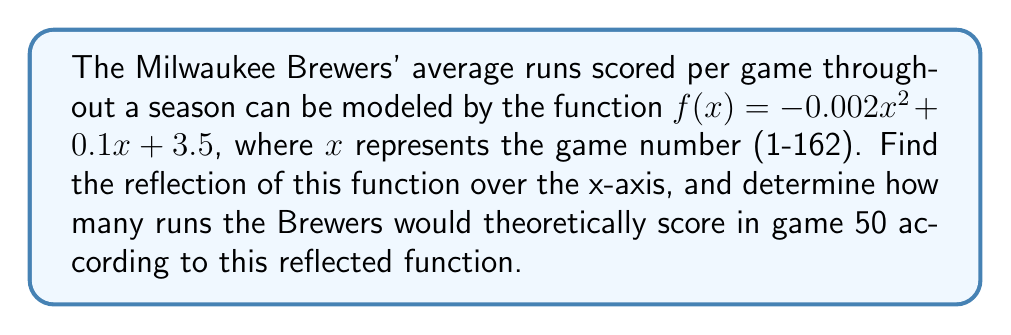Can you answer this question? To solve this problem, we'll follow these steps:

1) To reflect a function over the x-axis, we multiply the entire function by -1. This gives us:
   $g(x) = -f(x) = -(-0.002x^2 + 0.1x + 3.5)$
   
2) Simplify by distributing the negative sign:
   $g(x) = 0.002x^2 - 0.1x - 3.5$

3) Now we have our reflected function. To find the number of runs for game 50, we need to evaluate $g(50)$:

   $g(50) = 0.002(50)^2 - 0.1(50) - 3.5$

4) Let's calculate step by step:
   $= 0.002(2500) - 5 - 3.5$
   $= 5 - 5 - 3.5$
   $= -3.5$

5) Since runs scored can't be negative, we interpret this as the opposite of 3.5 runs scored.

Therefore, according to the reflected function, the Brewers would theoretically score 3.5 runs in game 50.
Answer: 3.5 runs 